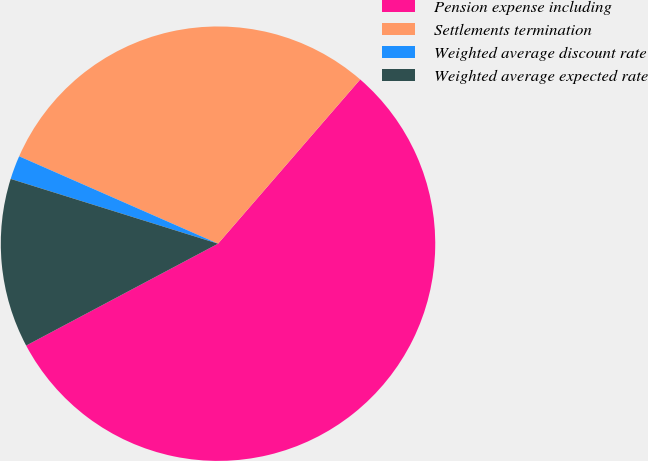Convert chart. <chart><loc_0><loc_0><loc_500><loc_500><pie_chart><fcel>Pension expense including<fcel>Settlements termination<fcel>Weighted average discount rate<fcel>Weighted average expected rate<nl><fcel>55.88%<fcel>29.77%<fcel>1.77%<fcel>12.59%<nl></chart> 